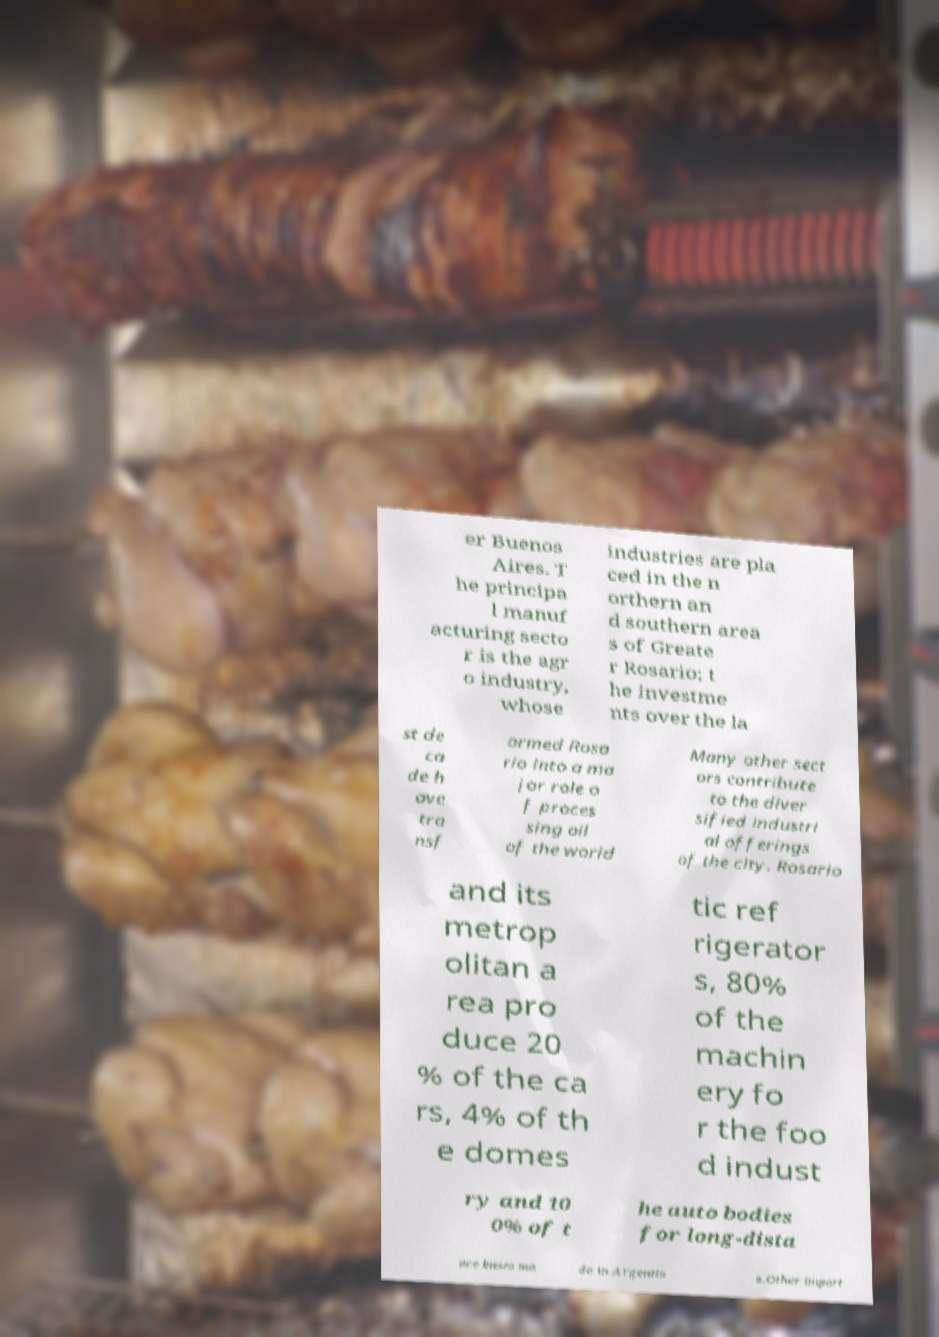What messages or text are displayed in this image? I need them in a readable, typed format. er Buenos Aires. T he principa l manuf acturing secto r is the agr o industry, whose industries are pla ced in the n orthern an d southern area s of Greate r Rosario; t he investme nts over the la st de ca de h ave tra nsf ormed Rosa rio into a ma jor role o f proces sing oil of the world Many other sect ors contribute to the diver sified industri al offerings of the city. Rosario and its metrop olitan a rea pro duce 20 % of the ca rs, 4% of th e domes tic ref rigerator s, 80% of the machin ery fo r the foo d indust ry and 10 0% of t he auto bodies for long-dista nce buses ma de in Argentin a.Other import 